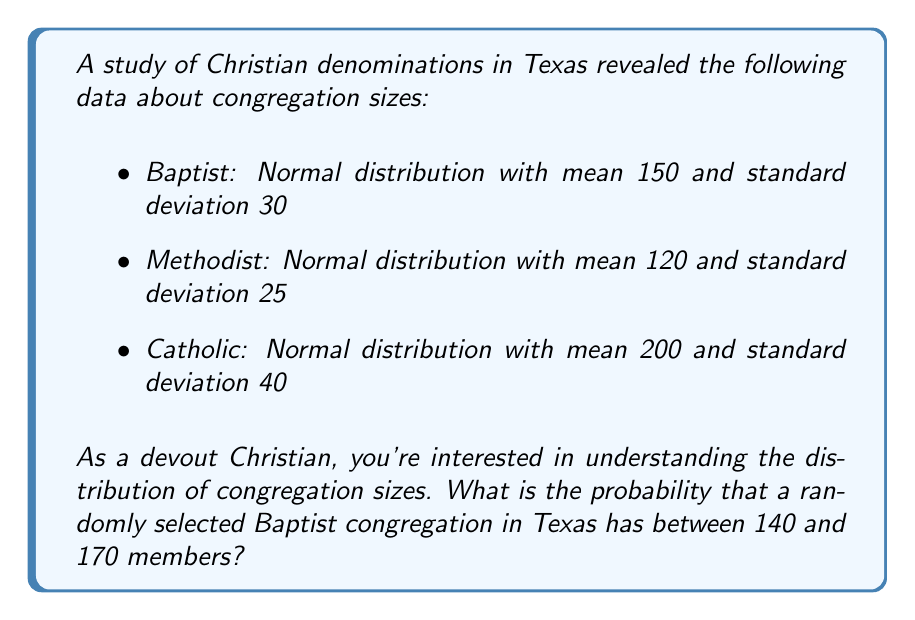What is the answer to this math problem? To solve this problem, we'll use the properties of the normal distribution and the z-score formula.

Step 1: Identify the relevant information
- Baptist congregations follow a normal distribution
- Mean (μ) = 150
- Standard deviation (σ) = 30
- We want the probability of a congregation size between 140 and 170

Step 2: Calculate the z-scores for the lower and upper bounds
z-score formula: $z = \frac{x - \mu}{\sigma}$

For x = 140: $z_1 = \frac{140 - 150}{30} = -\frac{10}{30} = -0.3333$

For x = 170: $z_2 = \frac{170 - 150}{30} = \frac{20}{30} = 0.6667$

Step 3: Use a standard normal distribution table or calculator to find the area between these z-scores

The area between z = -0.3333 and z = 0.6667 represents the probability we're looking for.

Using a calculator or standard normal table:
P(-0.3333 < Z < 0.6667) = P(Z < 0.6667) - P(Z < -0.3333)
                        = 0.7476 - 0.3694
                        = 0.3782

Step 4: Convert to percentage
0.3782 * 100 = 37.82%

Therefore, the probability that a randomly selected Baptist congregation in Texas has between 140 and 170 members is approximately 37.82%.
Answer: 37.82% 